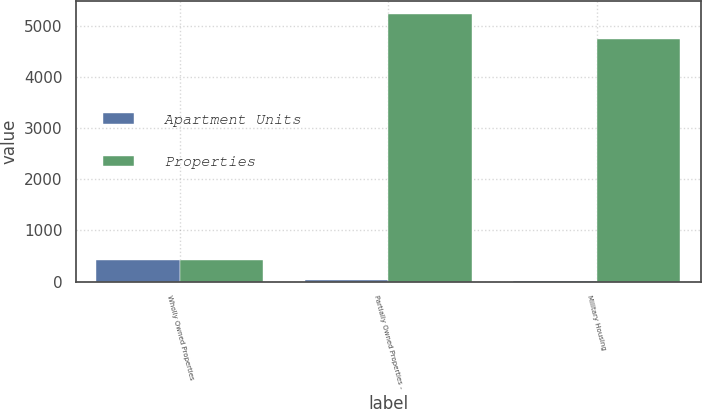Convert chart. <chart><loc_0><loc_0><loc_500><loc_500><stacked_bar_chart><ecel><fcel>Wholly Owned Properties<fcel>Partially Owned Properties -<fcel>Military Housing<nl><fcel>Apartment Units<fcel>425<fcel>24<fcel>2<nl><fcel>Properties<fcel>425<fcel>5232<fcel>4738<nl></chart> 